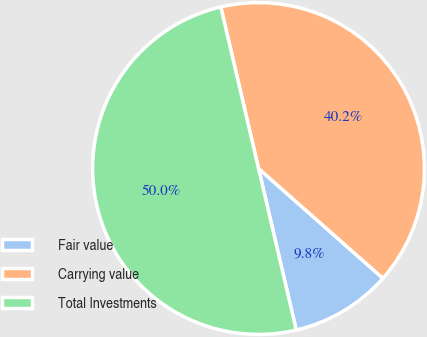<chart> <loc_0><loc_0><loc_500><loc_500><pie_chart><fcel>Fair value<fcel>Carrying value<fcel>Total Investments<nl><fcel>9.84%<fcel>40.16%<fcel>50.0%<nl></chart> 